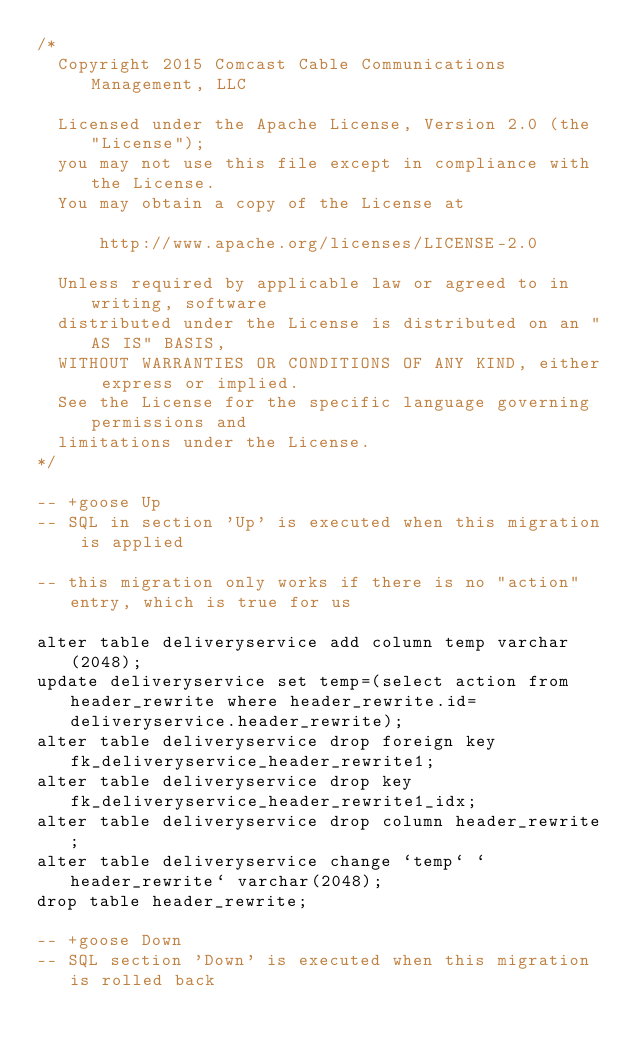<code> <loc_0><loc_0><loc_500><loc_500><_SQL_>/*
	Copyright 2015 Comcast Cable Communications Management, LLC
	
	Licensed under the Apache License, Version 2.0 (the "License");
	you may not use this file except in compliance with the License.
	You may obtain a copy of the License at
	
	    http://www.apache.org/licenses/LICENSE-2.0
	
	Unless required by applicable law or agreed to in writing, software
	distributed under the License is distributed on an "AS IS" BASIS,
	WITHOUT WARRANTIES OR CONDITIONS OF ANY KIND, either express or implied.
	See the License for the specific language governing permissions and
	limitations under the License.
*/

-- +goose Up
-- SQL in section 'Up' is executed when this migration is applied

-- this migration only works if there is no "action" entry, which is true for us

alter table deliveryservice add column temp varchar(2048);
update deliveryservice set temp=(select action from header_rewrite where header_rewrite.id=deliveryservice.header_rewrite);
alter table deliveryservice drop foreign key fk_deliveryservice_header_rewrite1;
alter table deliveryservice drop key fk_deliveryservice_header_rewrite1_idx;
alter table deliveryservice drop column header_rewrite;
alter table deliveryservice change `temp` `header_rewrite` varchar(2048);
drop table header_rewrite;

-- +goose Down
-- SQL section 'Down' is executed when this migration is rolled back
</code> 